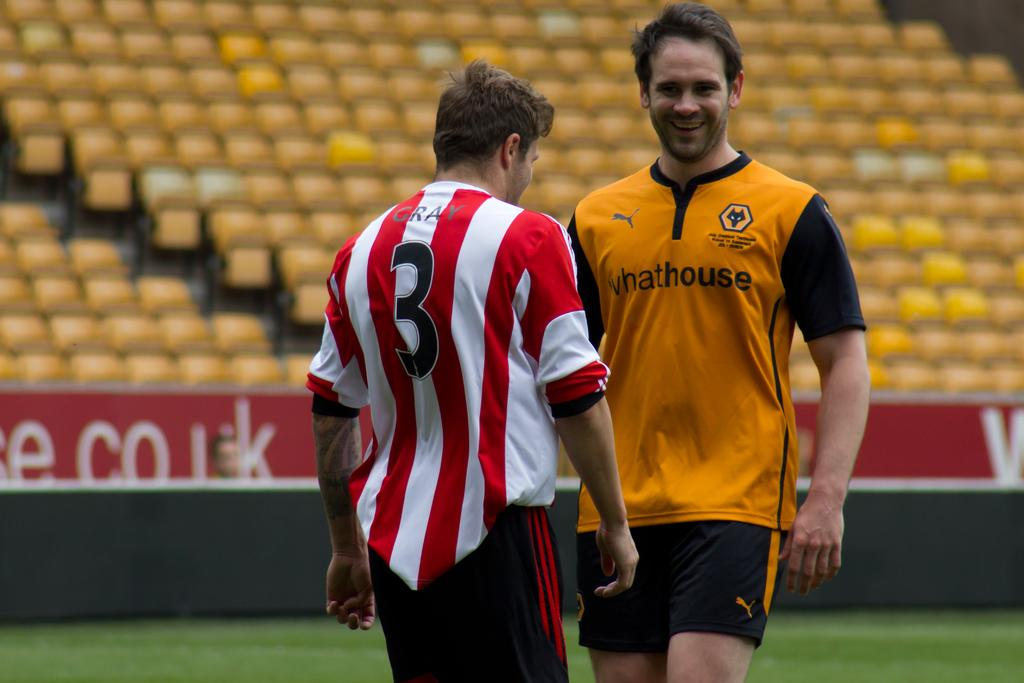<image>
Summarize the visual content of the image. A man wears an orange shirt with whathouse on the front. 